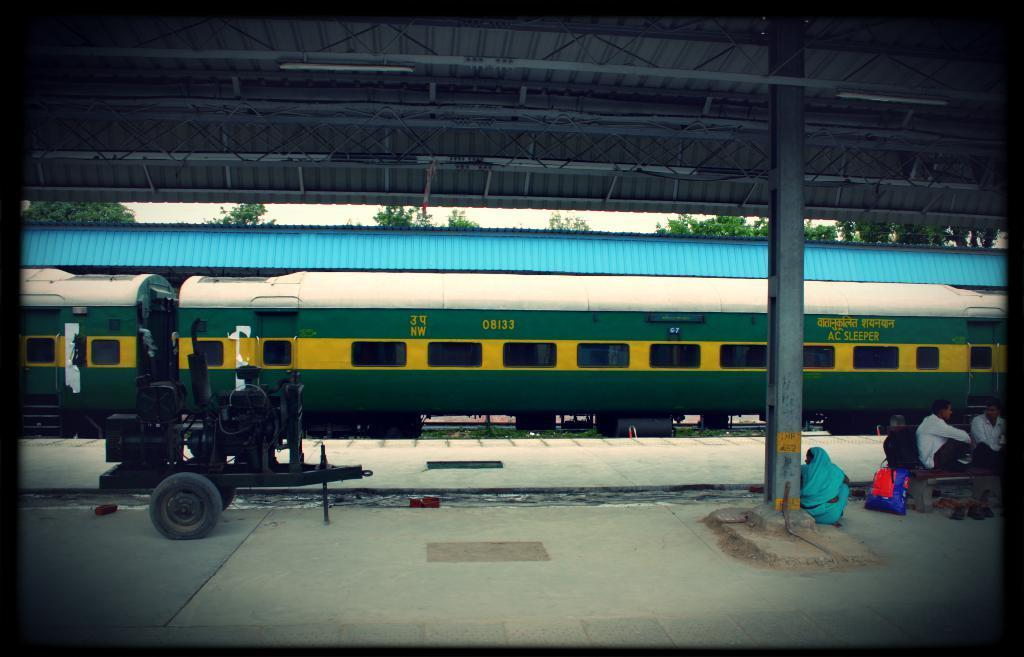Please provide a concise description of this image. In this image, we can see a train. We can see the ground. We can see a few people, a pole and a machine. We can also see some grass and trees. We can see the sky and the shed with some lights. 